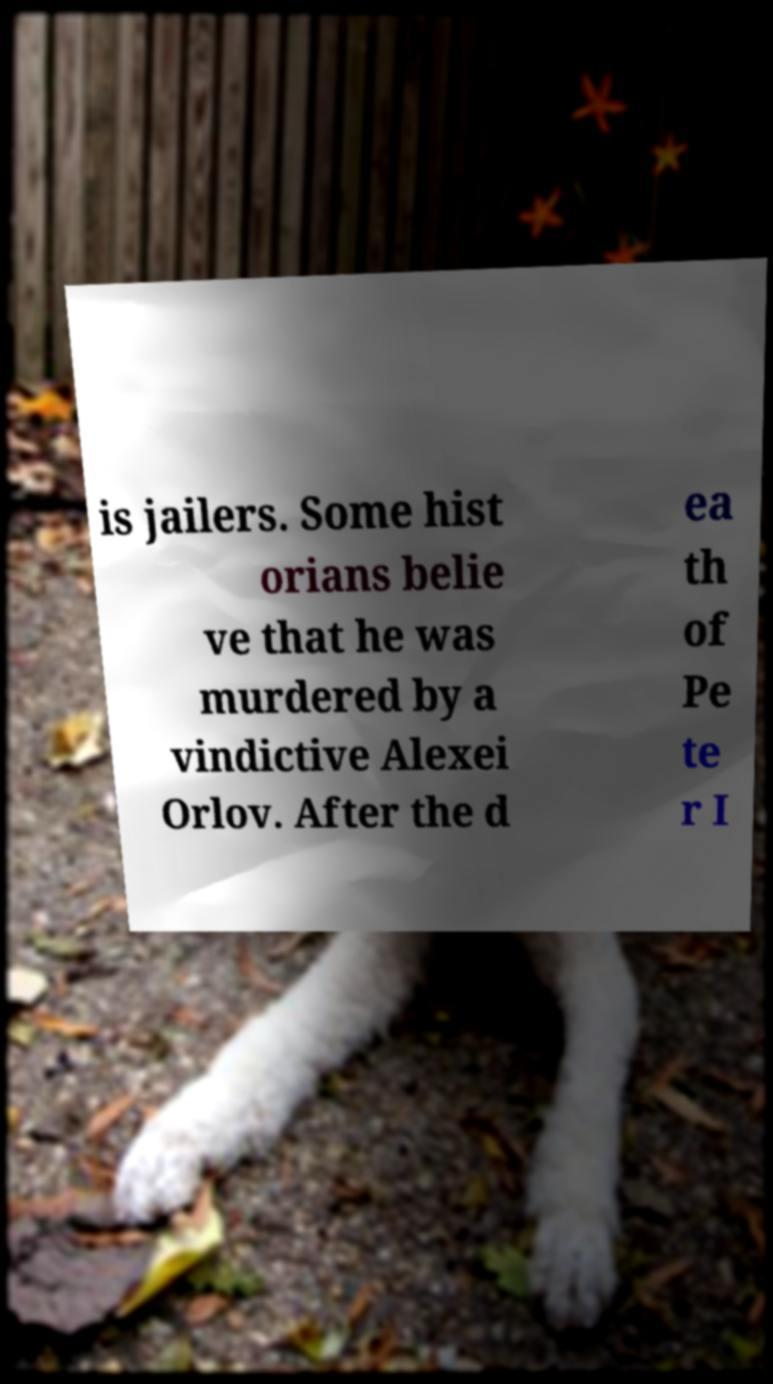What messages or text are displayed in this image? I need them in a readable, typed format. is jailers. Some hist orians belie ve that he was murdered by a vindictive Alexei Orlov. After the d ea th of Pe te r I 